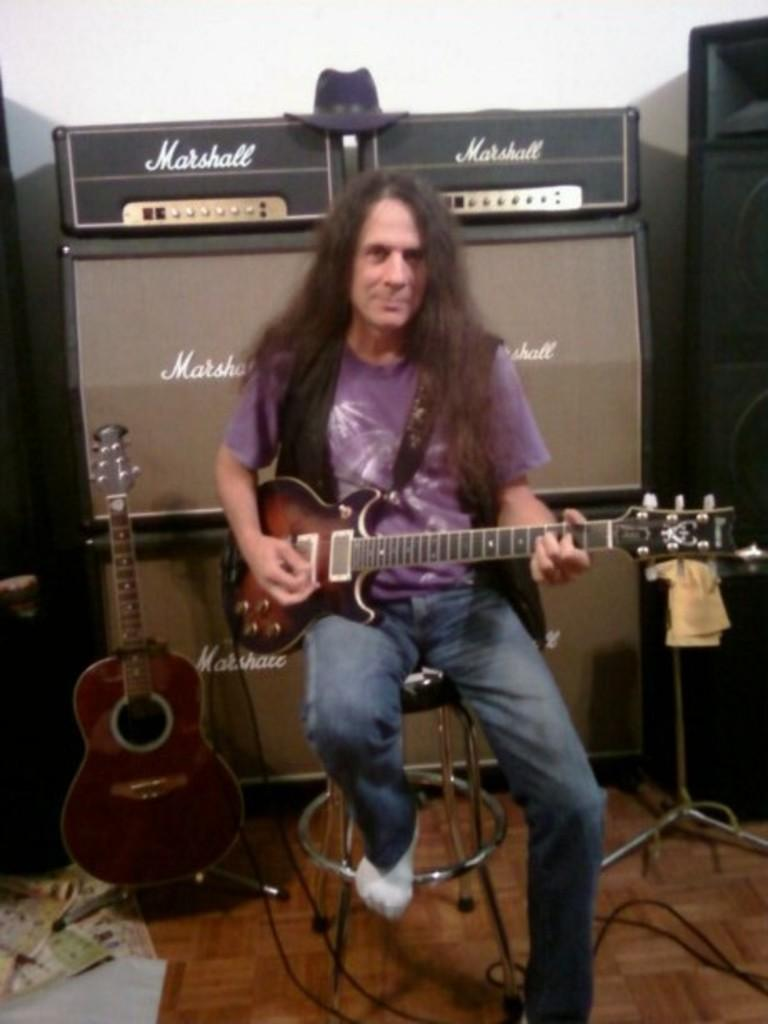What is the person in the image doing? The person is playing a musical instrument. What type of clothing is the person wearing? The person is wearing a blue shirt and blue jeans. What is the person sitting on in the image? The person is sitting on a chair. What musical instrument is the person playing? The person is playing a guitar. What additional objects can be seen in the image? There are speakers and a stand in the image. What type of apple is being used as a statement in the image? There is no apple or statement present in the image. 